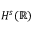<formula> <loc_0><loc_0><loc_500><loc_500>H ^ { s } ( \mathbb { R } )</formula> 